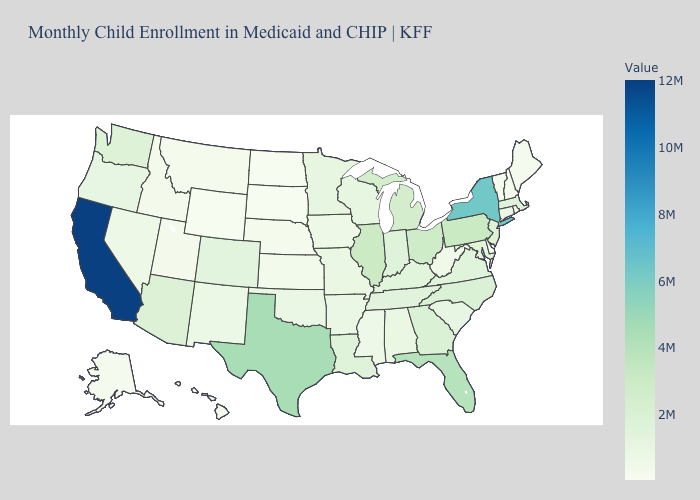Which states have the lowest value in the South?
Short answer required. Delaware. Among the states that border Minnesota , which have the highest value?
Be succinct. Wisconsin. 